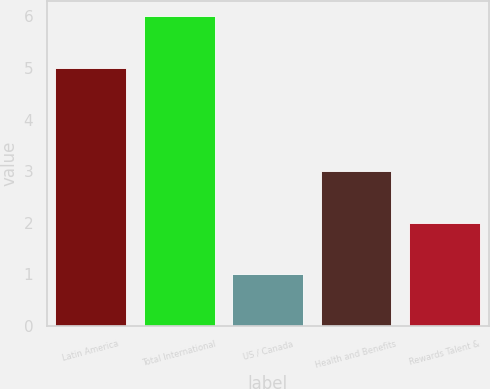Convert chart to OTSL. <chart><loc_0><loc_0><loc_500><loc_500><bar_chart><fcel>Latin America<fcel>Total International<fcel>US / Canada<fcel>Health and Benefits<fcel>Rewards Talent &<nl><fcel>5<fcel>6<fcel>1<fcel>3<fcel>2<nl></chart> 